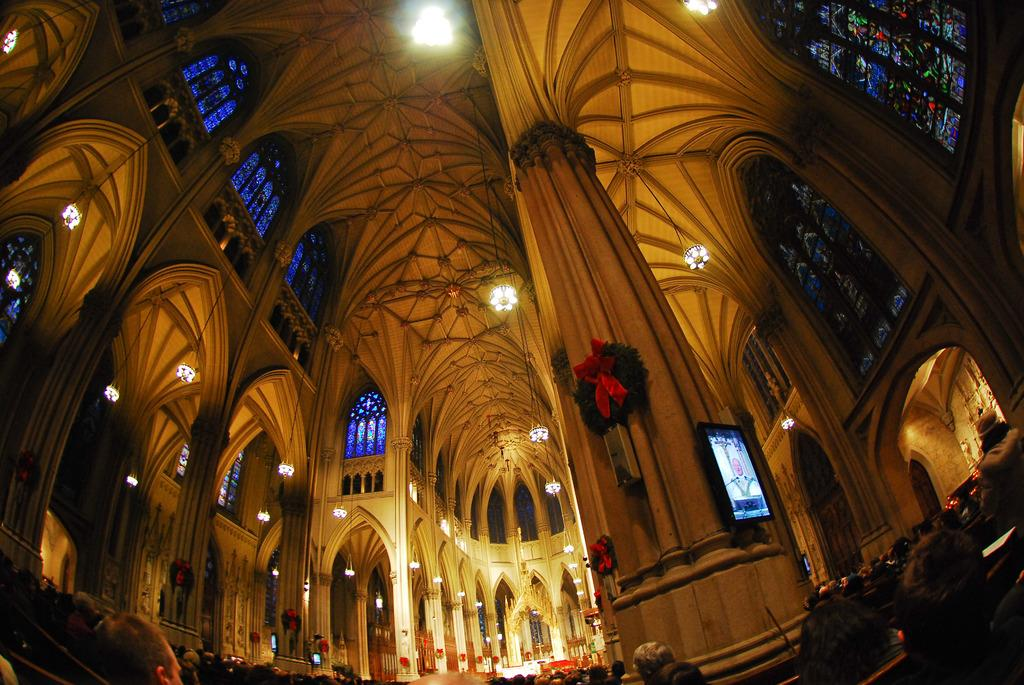What type of location is depicted in the image? The image is an inside view of a building. What can be seen illuminating the space in the image? There are lights visible in the image. What architectural feature is present in the image? There are pillars in the image. Who or what is present in the image? There are persons in the image. What allows natural light to enter the building in the image? There are windows in the image. What size of fan is being used by the persons in the image? There is no fan visible in the image. How is the size of the building being measured in the image? The size of the building cannot be measured from the image alone, as it only provides a partial view of the interior. 